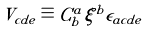<formula> <loc_0><loc_0><loc_500><loc_500>V _ { c d e } \equiv C ^ { a } _ { b } \xi ^ { b } \epsilon _ { a c d e }</formula> 